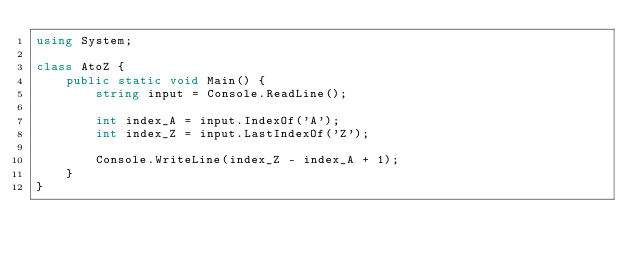Convert code to text. <code><loc_0><loc_0><loc_500><loc_500><_C#_>using System;

class AtoZ {
    public static void Main() {
        string input = Console.ReadLine();

        int index_A = input.IndexOf('A');
        int index_Z = input.LastIndexOf('Z');

        Console.WriteLine(index_Z - index_A + 1);
    }
}</code> 